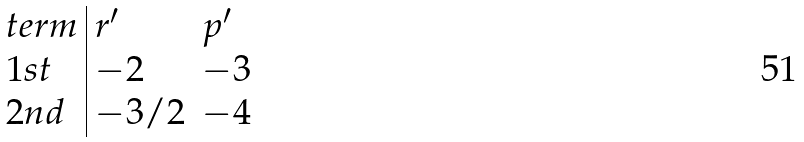Convert formula to latex. <formula><loc_0><loc_0><loc_500><loc_500>\begin{array} { l | l l } t e r m & r ^ { \prime } & p ^ { \prime } \\ 1 s t & - 2 & - 3 \\ 2 n d & - 3 / 2 & - 4 \end{array}</formula> 